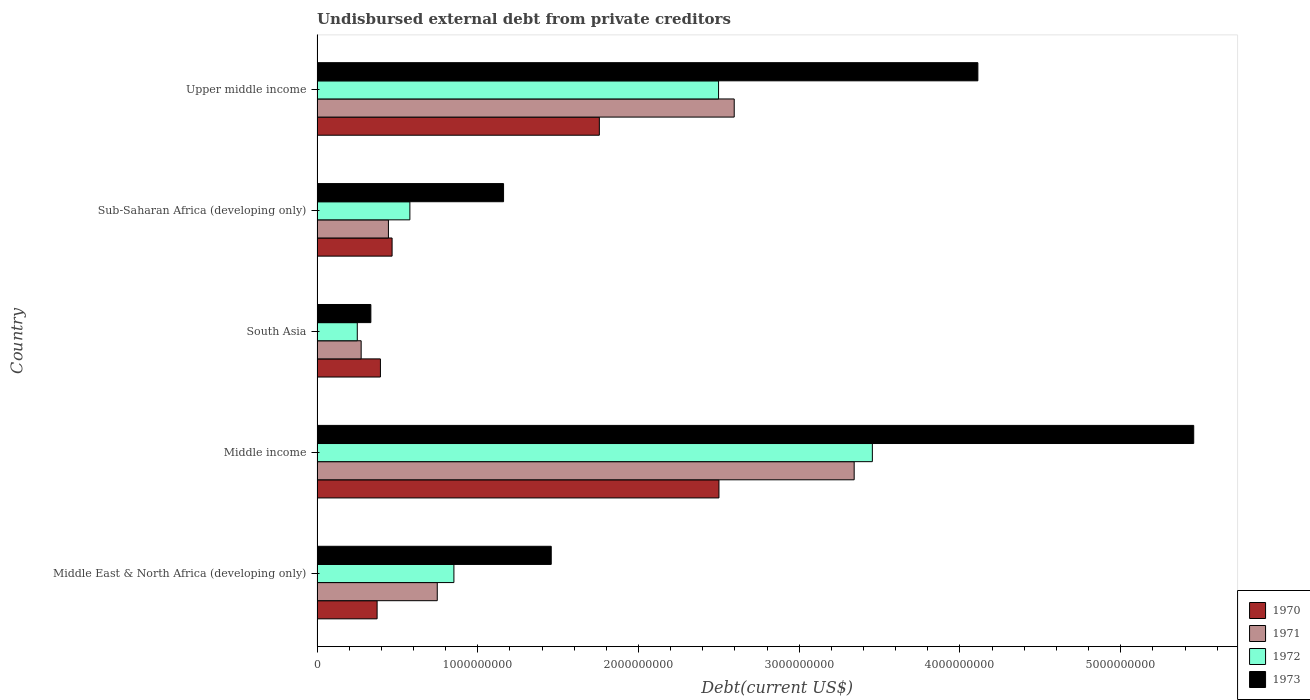How many groups of bars are there?
Make the answer very short. 5. Are the number of bars on each tick of the Y-axis equal?
Make the answer very short. Yes. What is the label of the 5th group of bars from the top?
Make the answer very short. Middle East & North Africa (developing only). What is the total debt in 1973 in Upper middle income?
Your response must be concise. 4.11e+09. Across all countries, what is the maximum total debt in 1971?
Ensure brevity in your answer.  3.34e+09. Across all countries, what is the minimum total debt in 1971?
Offer a very short reply. 2.74e+08. In which country was the total debt in 1970 minimum?
Give a very brief answer. Middle East & North Africa (developing only). What is the total total debt in 1973 in the graph?
Offer a very short reply. 1.25e+1. What is the difference between the total debt in 1970 in South Asia and that in Upper middle income?
Your answer should be compact. -1.36e+09. What is the difference between the total debt in 1971 in Sub-Saharan Africa (developing only) and the total debt in 1973 in Middle income?
Keep it short and to the point. -5.01e+09. What is the average total debt in 1971 per country?
Make the answer very short. 1.48e+09. What is the difference between the total debt in 1970 and total debt in 1972 in South Asia?
Your answer should be very brief. 1.44e+08. What is the ratio of the total debt in 1973 in Middle East & North Africa (developing only) to that in Sub-Saharan Africa (developing only)?
Your answer should be very brief. 1.26. Is the total debt in 1972 in Middle income less than that in South Asia?
Your answer should be compact. No. Is the difference between the total debt in 1970 in Middle income and Sub-Saharan Africa (developing only) greater than the difference between the total debt in 1972 in Middle income and Sub-Saharan Africa (developing only)?
Offer a terse response. No. What is the difference between the highest and the second highest total debt in 1972?
Offer a very short reply. 9.57e+08. What is the difference between the highest and the lowest total debt in 1971?
Ensure brevity in your answer.  3.07e+09. Is it the case that in every country, the sum of the total debt in 1972 and total debt in 1970 is greater than the sum of total debt in 1973 and total debt in 1971?
Your answer should be compact. No. Is it the case that in every country, the sum of the total debt in 1970 and total debt in 1973 is greater than the total debt in 1971?
Keep it short and to the point. Yes. Are the values on the major ticks of X-axis written in scientific E-notation?
Provide a succinct answer. No. How many legend labels are there?
Offer a terse response. 4. What is the title of the graph?
Make the answer very short. Undisbursed external debt from private creditors. What is the label or title of the X-axis?
Provide a short and direct response. Debt(current US$). What is the label or title of the Y-axis?
Ensure brevity in your answer.  Country. What is the Debt(current US$) of 1970 in Middle East & North Africa (developing only)?
Give a very brief answer. 3.74e+08. What is the Debt(current US$) in 1971 in Middle East & North Africa (developing only)?
Offer a terse response. 7.48e+08. What is the Debt(current US$) in 1972 in Middle East & North Africa (developing only)?
Your response must be concise. 8.51e+08. What is the Debt(current US$) of 1973 in Middle East & North Africa (developing only)?
Ensure brevity in your answer.  1.46e+09. What is the Debt(current US$) of 1970 in Middle income?
Offer a terse response. 2.50e+09. What is the Debt(current US$) of 1971 in Middle income?
Make the answer very short. 3.34e+09. What is the Debt(current US$) of 1972 in Middle income?
Offer a very short reply. 3.45e+09. What is the Debt(current US$) in 1973 in Middle income?
Your answer should be very brief. 5.45e+09. What is the Debt(current US$) of 1970 in South Asia?
Keep it short and to the point. 3.94e+08. What is the Debt(current US$) of 1971 in South Asia?
Ensure brevity in your answer.  2.74e+08. What is the Debt(current US$) of 1972 in South Asia?
Provide a succinct answer. 2.50e+08. What is the Debt(current US$) in 1973 in South Asia?
Your answer should be compact. 3.35e+08. What is the Debt(current US$) of 1970 in Sub-Saharan Africa (developing only)?
Your answer should be compact. 4.67e+08. What is the Debt(current US$) in 1971 in Sub-Saharan Africa (developing only)?
Provide a short and direct response. 4.44e+08. What is the Debt(current US$) of 1972 in Sub-Saharan Africa (developing only)?
Make the answer very short. 5.77e+08. What is the Debt(current US$) in 1973 in Sub-Saharan Africa (developing only)?
Keep it short and to the point. 1.16e+09. What is the Debt(current US$) of 1970 in Upper middle income?
Your response must be concise. 1.76e+09. What is the Debt(current US$) in 1971 in Upper middle income?
Make the answer very short. 2.60e+09. What is the Debt(current US$) of 1972 in Upper middle income?
Offer a very short reply. 2.50e+09. What is the Debt(current US$) in 1973 in Upper middle income?
Your answer should be very brief. 4.11e+09. Across all countries, what is the maximum Debt(current US$) in 1970?
Give a very brief answer. 2.50e+09. Across all countries, what is the maximum Debt(current US$) in 1971?
Give a very brief answer. 3.34e+09. Across all countries, what is the maximum Debt(current US$) in 1972?
Keep it short and to the point. 3.45e+09. Across all countries, what is the maximum Debt(current US$) of 1973?
Your response must be concise. 5.45e+09. Across all countries, what is the minimum Debt(current US$) in 1970?
Your answer should be very brief. 3.74e+08. Across all countries, what is the minimum Debt(current US$) of 1971?
Provide a succinct answer. 2.74e+08. Across all countries, what is the minimum Debt(current US$) in 1972?
Offer a very short reply. 2.50e+08. Across all countries, what is the minimum Debt(current US$) in 1973?
Your response must be concise. 3.35e+08. What is the total Debt(current US$) in 1970 in the graph?
Your answer should be compact. 5.49e+09. What is the total Debt(current US$) of 1971 in the graph?
Provide a short and direct response. 7.40e+09. What is the total Debt(current US$) of 1972 in the graph?
Provide a short and direct response. 7.63e+09. What is the total Debt(current US$) of 1973 in the graph?
Keep it short and to the point. 1.25e+1. What is the difference between the Debt(current US$) of 1970 in Middle East & North Africa (developing only) and that in Middle income?
Your answer should be very brief. -2.13e+09. What is the difference between the Debt(current US$) of 1971 in Middle East & North Africa (developing only) and that in Middle income?
Provide a succinct answer. -2.59e+09. What is the difference between the Debt(current US$) in 1972 in Middle East & North Africa (developing only) and that in Middle income?
Provide a succinct answer. -2.60e+09. What is the difference between the Debt(current US$) of 1973 in Middle East & North Africa (developing only) and that in Middle income?
Make the answer very short. -4.00e+09. What is the difference between the Debt(current US$) in 1970 in Middle East & North Africa (developing only) and that in South Asia?
Offer a terse response. -2.07e+07. What is the difference between the Debt(current US$) in 1971 in Middle East & North Africa (developing only) and that in South Asia?
Your answer should be very brief. 4.74e+08. What is the difference between the Debt(current US$) of 1972 in Middle East & North Africa (developing only) and that in South Asia?
Your answer should be very brief. 6.01e+08. What is the difference between the Debt(current US$) in 1973 in Middle East & North Africa (developing only) and that in South Asia?
Offer a terse response. 1.12e+09. What is the difference between the Debt(current US$) in 1970 in Middle East & North Africa (developing only) and that in Sub-Saharan Africa (developing only)?
Ensure brevity in your answer.  -9.32e+07. What is the difference between the Debt(current US$) of 1971 in Middle East & North Africa (developing only) and that in Sub-Saharan Africa (developing only)?
Give a very brief answer. 3.04e+08. What is the difference between the Debt(current US$) of 1972 in Middle East & North Africa (developing only) and that in Sub-Saharan Africa (developing only)?
Provide a short and direct response. 2.74e+08. What is the difference between the Debt(current US$) of 1973 in Middle East & North Africa (developing only) and that in Sub-Saharan Africa (developing only)?
Your answer should be compact. 2.97e+08. What is the difference between the Debt(current US$) of 1970 in Middle East & North Africa (developing only) and that in Upper middle income?
Give a very brief answer. -1.38e+09. What is the difference between the Debt(current US$) of 1971 in Middle East & North Africa (developing only) and that in Upper middle income?
Give a very brief answer. -1.85e+09. What is the difference between the Debt(current US$) in 1972 in Middle East & North Africa (developing only) and that in Upper middle income?
Offer a very short reply. -1.65e+09. What is the difference between the Debt(current US$) in 1973 in Middle East & North Africa (developing only) and that in Upper middle income?
Your response must be concise. -2.65e+09. What is the difference between the Debt(current US$) of 1970 in Middle income and that in South Asia?
Your answer should be very brief. 2.11e+09. What is the difference between the Debt(current US$) in 1971 in Middle income and that in South Asia?
Ensure brevity in your answer.  3.07e+09. What is the difference between the Debt(current US$) in 1972 in Middle income and that in South Asia?
Ensure brevity in your answer.  3.20e+09. What is the difference between the Debt(current US$) in 1973 in Middle income and that in South Asia?
Make the answer very short. 5.12e+09. What is the difference between the Debt(current US$) in 1970 in Middle income and that in Sub-Saharan Africa (developing only)?
Ensure brevity in your answer.  2.03e+09. What is the difference between the Debt(current US$) of 1971 in Middle income and that in Sub-Saharan Africa (developing only)?
Provide a succinct answer. 2.90e+09. What is the difference between the Debt(current US$) of 1972 in Middle income and that in Sub-Saharan Africa (developing only)?
Your answer should be compact. 2.88e+09. What is the difference between the Debt(current US$) of 1973 in Middle income and that in Sub-Saharan Africa (developing only)?
Keep it short and to the point. 4.29e+09. What is the difference between the Debt(current US$) in 1970 in Middle income and that in Upper middle income?
Provide a succinct answer. 7.44e+08. What is the difference between the Debt(current US$) of 1971 in Middle income and that in Upper middle income?
Make the answer very short. 7.46e+08. What is the difference between the Debt(current US$) of 1972 in Middle income and that in Upper middle income?
Provide a succinct answer. 9.57e+08. What is the difference between the Debt(current US$) of 1973 in Middle income and that in Upper middle income?
Your answer should be very brief. 1.34e+09. What is the difference between the Debt(current US$) of 1970 in South Asia and that in Sub-Saharan Africa (developing only)?
Provide a succinct answer. -7.26e+07. What is the difference between the Debt(current US$) of 1971 in South Asia and that in Sub-Saharan Africa (developing only)?
Offer a terse response. -1.70e+08. What is the difference between the Debt(current US$) in 1972 in South Asia and that in Sub-Saharan Africa (developing only)?
Provide a short and direct response. -3.27e+08. What is the difference between the Debt(current US$) of 1973 in South Asia and that in Sub-Saharan Africa (developing only)?
Keep it short and to the point. -8.26e+08. What is the difference between the Debt(current US$) of 1970 in South Asia and that in Upper middle income?
Offer a terse response. -1.36e+09. What is the difference between the Debt(current US$) of 1971 in South Asia and that in Upper middle income?
Your response must be concise. -2.32e+09. What is the difference between the Debt(current US$) of 1972 in South Asia and that in Upper middle income?
Offer a very short reply. -2.25e+09. What is the difference between the Debt(current US$) of 1973 in South Asia and that in Upper middle income?
Ensure brevity in your answer.  -3.78e+09. What is the difference between the Debt(current US$) in 1970 in Sub-Saharan Africa (developing only) and that in Upper middle income?
Make the answer very short. -1.29e+09. What is the difference between the Debt(current US$) of 1971 in Sub-Saharan Africa (developing only) and that in Upper middle income?
Ensure brevity in your answer.  -2.15e+09. What is the difference between the Debt(current US$) in 1972 in Sub-Saharan Africa (developing only) and that in Upper middle income?
Ensure brevity in your answer.  -1.92e+09. What is the difference between the Debt(current US$) of 1973 in Sub-Saharan Africa (developing only) and that in Upper middle income?
Your answer should be compact. -2.95e+09. What is the difference between the Debt(current US$) of 1970 in Middle East & North Africa (developing only) and the Debt(current US$) of 1971 in Middle income?
Ensure brevity in your answer.  -2.97e+09. What is the difference between the Debt(current US$) in 1970 in Middle East & North Africa (developing only) and the Debt(current US$) in 1972 in Middle income?
Provide a succinct answer. -3.08e+09. What is the difference between the Debt(current US$) in 1970 in Middle East & North Africa (developing only) and the Debt(current US$) in 1973 in Middle income?
Make the answer very short. -5.08e+09. What is the difference between the Debt(current US$) of 1971 in Middle East & North Africa (developing only) and the Debt(current US$) of 1972 in Middle income?
Offer a very short reply. -2.71e+09. What is the difference between the Debt(current US$) in 1971 in Middle East & North Africa (developing only) and the Debt(current US$) in 1973 in Middle income?
Your answer should be very brief. -4.71e+09. What is the difference between the Debt(current US$) of 1972 in Middle East & North Africa (developing only) and the Debt(current US$) of 1973 in Middle income?
Offer a terse response. -4.60e+09. What is the difference between the Debt(current US$) in 1970 in Middle East & North Africa (developing only) and the Debt(current US$) in 1971 in South Asia?
Your answer should be compact. 9.92e+07. What is the difference between the Debt(current US$) of 1970 in Middle East & North Africa (developing only) and the Debt(current US$) of 1972 in South Asia?
Offer a terse response. 1.23e+08. What is the difference between the Debt(current US$) of 1970 in Middle East & North Africa (developing only) and the Debt(current US$) of 1973 in South Asia?
Your response must be concise. 3.88e+07. What is the difference between the Debt(current US$) of 1971 in Middle East & North Africa (developing only) and the Debt(current US$) of 1972 in South Asia?
Provide a succinct answer. 4.98e+08. What is the difference between the Debt(current US$) of 1971 in Middle East & North Africa (developing only) and the Debt(current US$) of 1973 in South Asia?
Offer a very short reply. 4.13e+08. What is the difference between the Debt(current US$) in 1972 in Middle East & North Africa (developing only) and the Debt(current US$) in 1973 in South Asia?
Make the answer very short. 5.17e+08. What is the difference between the Debt(current US$) in 1970 in Middle East & North Africa (developing only) and the Debt(current US$) in 1971 in Sub-Saharan Africa (developing only)?
Your response must be concise. -7.04e+07. What is the difference between the Debt(current US$) in 1970 in Middle East & North Africa (developing only) and the Debt(current US$) in 1972 in Sub-Saharan Africa (developing only)?
Ensure brevity in your answer.  -2.04e+08. What is the difference between the Debt(current US$) of 1970 in Middle East & North Africa (developing only) and the Debt(current US$) of 1973 in Sub-Saharan Africa (developing only)?
Offer a terse response. -7.87e+08. What is the difference between the Debt(current US$) of 1971 in Middle East & North Africa (developing only) and the Debt(current US$) of 1972 in Sub-Saharan Africa (developing only)?
Offer a very short reply. 1.70e+08. What is the difference between the Debt(current US$) in 1971 in Middle East & North Africa (developing only) and the Debt(current US$) in 1973 in Sub-Saharan Africa (developing only)?
Your response must be concise. -4.12e+08. What is the difference between the Debt(current US$) of 1972 in Middle East & North Africa (developing only) and the Debt(current US$) of 1973 in Sub-Saharan Africa (developing only)?
Give a very brief answer. -3.09e+08. What is the difference between the Debt(current US$) of 1970 in Middle East & North Africa (developing only) and the Debt(current US$) of 1971 in Upper middle income?
Offer a terse response. -2.22e+09. What is the difference between the Debt(current US$) in 1970 in Middle East & North Africa (developing only) and the Debt(current US$) in 1972 in Upper middle income?
Offer a very short reply. -2.12e+09. What is the difference between the Debt(current US$) in 1970 in Middle East & North Africa (developing only) and the Debt(current US$) in 1973 in Upper middle income?
Make the answer very short. -3.74e+09. What is the difference between the Debt(current US$) of 1971 in Middle East & North Africa (developing only) and the Debt(current US$) of 1972 in Upper middle income?
Give a very brief answer. -1.75e+09. What is the difference between the Debt(current US$) of 1971 in Middle East & North Africa (developing only) and the Debt(current US$) of 1973 in Upper middle income?
Make the answer very short. -3.36e+09. What is the difference between the Debt(current US$) of 1972 in Middle East & North Africa (developing only) and the Debt(current US$) of 1973 in Upper middle income?
Provide a succinct answer. -3.26e+09. What is the difference between the Debt(current US$) of 1970 in Middle income and the Debt(current US$) of 1971 in South Asia?
Offer a terse response. 2.23e+09. What is the difference between the Debt(current US$) in 1970 in Middle income and the Debt(current US$) in 1972 in South Asia?
Provide a succinct answer. 2.25e+09. What is the difference between the Debt(current US$) in 1970 in Middle income and the Debt(current US$) in 1973 in South Asia?
Your answer should be compact. 2.17e+09. What is the difference between the Debt(current US$) of 1971 in Middle income and the Debt(current US$) of 1972 in South Asia?
Provide a short and direct response. 3.09e+09. What is the difference between the Debt(current US$) in 1971 in Middle income and the Debt(current US$) in 1973 in South Asia?
Your answer should be compact. 3.01e+09. What is the difference between the Debt(current US$) of 1972 in Middle income and the Debt(current US$) of 1973 in South Asia?
Offer a terse response. 3.12e+09. What is the difference between the Debt(current US$) of 1970 in Middle income and the Debt(current US$) of 1971 in Sub-Saharan Africa (developing only)?
Provide a succinct answer. 2.06e+09. What is the difference between the Debt(current US$) in 1970 in Middle income and the Debt(current US$) in 1972 in Sub-Saharan Africa (developing only)?
Keep it short and to the point. 1.92e+09. What is the difference between the Debt(current US$) in 1970 in Middle income and the Debt(current US$) in 1973 in Sub-Saharan Africa (developing only)?
Offer a very short reply. 1.34e+09. What is the difference between the Debt(current US$) of 1971 in Middle income and the Debt(current US$) of 1972 in Sub-Saharan Africa (developing only)?
Offer a very short reply. 2.76e+09. What is the difference between the Debt(current US$) of 1971 in Middle income and the Debt(current US$) of 1973 in Sub-Saharan Africa (developing only)?
Your response must be concise. 2.18e+09. What is the difference between the Debt(current US$) in 1972 in Middle income and the Debt(current US$) in 1973 in Sub-Saharan Africa (developing only)?
Provide a succinct answer. 2.29e+09. What is the difference between the Debt(current US$) in 1970 in Middle income and the Debt(current US$) in 1971 in Upper middle income?
Keep it short and to the point. -9.50e+07. What is the difference between the Debt(current US$) in 1970 in Middle income and the Debt(current US$) in 1972 in Upper middle income?
Make the answer very short. 2.49e+06. What is the difference between the Debt(current US$) of 1970 in Middle income and the Debt(current US$) of 1973 in Upper middle income?
Offer a very short reply. -1.61e+09. What is the difference between the Debt(current US$) in 1971 in Middle income and the Debt(current US$) in 1972 in Upper middle income?
Your answer should be very brief. 8.44e+08. What is the difference between the Debt(current US$) in 1971 in Middle income and the Debt(current US$) in 1973 in Upper middle income?
Your answer should be very brief. -7.70e+08. What is the difference between the Debt(current US$) in 1972 in Middle income and the Debt(current US$) in 1973 in Upper middle income?
Ensure brevity in your answer.  -6.57e+08. What is the difference between the Debt(current US$) in 1970 in South Asia and the Debt(current US$) in 1971 in Sub-Saharan Africa (developing only)?
Your answer should be very brief. -4.98e+07. What is the difference between the Debt(current US$) in 1970 in South Asia and the Debt(current US$) in 1972 in Sub-Saharan Africa (developing only)?
Offer a terse response. -1.83e+08. What is the difference between the Debt(current US$) in 1970 in South Asia and the Debt(current US$) in 1973 in Sub-Saharan Africa (developing only)?
Ensure brevity in your answer.  -7.66e+08. What is the difference between the Debt(current US$) in 1971 in South Asia and the Debt(current US$) in 1972 in Sub-Saharan Africa (developing only)?
Offer a very short reply. -3.03e+08. What is the difference between the Debt(current US$) of 1971 in South Asia and the Debt(current US$) of 1973 in Sub-Saharan Africa (developing only)?
Provide a succinct answer. -8.86e+08. What is the difference between the Debt(current US$) in 1972 in South Asia and the Debt(current US$) in 1973 in Sub-Saharan Africa (developing only)?
Give a very brief answer. -9.10e+08. What is the difference between the Debt(current US$) of 1970 in South Asia and the Debt(current US$) of 1971 in Upper middle income?
Give a very brief answer. -2.20e+09. What is the difference between the Debt(current US$) of 1970 in South Asia and the Debt(current US$) of 1972 in Upper middle income?
Keep it short and to the point. -2.10e+09. What is the difference between the Debt(current US$) of 1970 in South Asia and the Debt(current US$) of 1973 in Upper middle income?
Give a very brief answer. -3.72e+09. What is the difference between the Debt(current US$) of 1971 in South Asia and the Debt(current US$) of 1972 in Upper middle income?
Provide a succinct answer. -2.22e+09. What is the difference between the Debt(current US$) in 1971 in South Asia and the Debt(current US$) in 1973 in Upper middle income?
Offer a terse response. -3.84e+09. What is the difference between the Debt(current US$) of 1972 in South Asia and the Debt(current US$) of 1973 in Upper middle income?
Keep it short and to the point. -3.86e+09. What is the difference between the Debt(current US$) in 1970 in Sub-Saharan Africa (developing only) and the Debt(current US$) in 1971 in Upper middle income?
Offer a terse response. -2.13e+09. What is the difference between the Debt(current US$) of 1970 in Sub-Saharan Africa (developing only) and the Debt(current US$) of 1972 in Upper middle income?
Offer a very short reply. -2.03e+09. What is the difference between the Debt(current US$) in 1970 in Sub-Saharan Africa (developing only) and the Debt(current US$) in 1973 in Upper middle income?
Your answer should be compact. -3.64e+09. What is the difference between the Debt(current US$) in 1971 in Sub-Saharan Africa (developing only) and the Debt(current US$) in 1972 in Upper middle income?
Keep it short and to the point. -2.05e+09. What is the difference between the Debt(current US$) of 1971 in Sub-Saharan Africa (developing only) and the Debt(current US$) of 1973 in Upper middle income?
Give a very brief answer. -3.67e+09. What is the difference between the Debt(current US$) of 1972 in Sub-Saharan Africa (developing only) and the Debt(current US$) of 1973 in Upper middle income?
Provide a short and direct response. -3.53e+09. What is the average Debt(current US$) in 1970 per country?
Your answer should be very brief. 1.10e+09. What is the average Debt(current US$) of 1971 per country?
Keep it short and to the point. 1.48e+09. What is the average Debt(current US$) of 1972 per country?
Provide a short and direct response. 1.53e+09. What is the average Debt(current US$) of 1973 per country?
Your answer should be compact. 2.50e+09. What is the difference between the Debt(current US$) in 1970 and Debt(current US$) in 1971 in Middle East & North Africa (developing only)?
Your answer should be compact. -3.74e+08. What is the difference between the Debt(current US$) of 1970 and Debt(current US$) of 1972 in Middle East & North Africa (developing only)?
Your answer should be very brief. -4.78e+08. What is the difference between the Debt(current US$) of 1970 and Debt(current US$) of 1973 in Middle East & North Africa (developing only)?
Provide a succinct answer. -1.08e+09. What is the difference between the Debt(current US$) of 1971 and Debt(current US$) of 1972 in Middle East & North Africa (developing only)?
Keep it short and to the point. -1.04e+08. What is the difference between the Debt(current US$) of 1971 and Debt(current US$) of 1973 in Middle East & North Africa (developing only)?
Your answer should be compact. -7.09e+08. What is the difference between the Debt(current US$) of 1972 and Debt(current US$) of 1973 in Middle East & North Africa (developing only)?
Provide a short and direct response. -6.06e+08. What is the difference between the Debt(current US$) of 1970 and Debt(current US$) of 1971 in Middle income?
Your response must be concise. -8.41e+08. What is the difference between the Debt(current US$) of 1970 and Debt(current US$) of 1972 in Middle income?
Provide a short and direct response. -9.54e+08. What is the difference between the Debt(current US$) of 1970 and Debt(current US$) of 1973 in Middle income?
Provide a succinct answer. -2.95e+09. What is the difference between the Debt(current US$) of 1971 and Debt(current US$) of 1972 in Middle income?
Make the answer very short. -1.13e+08. What is the difference between the Debt(current US$) of 1971 and Debt(current US$) of 1973 in Middle income?
Keep it short and to the point. -2.11e+09. What is the difference between the Debt(current US$) in 1972 and Debt(current US$) in 1973 in Middle income?
Make the answer very short. -2.00e+09. What is the difference between the Debt(current US$) in 1970 and Debt(current US$) in 1971 in South Asia?
Keep it short and to the point. 1.20e+08. What is the difference between the Debt(current US$) of 1970 and Debt(current US$) of 1972 in South Asia?
Your answer should be compact. 1.44e+08. What is the difference between the Debt(current US$) of 1970 and Debt(current US$) of 1973 in South Asia?
Your response must be concise. 5.95e+07. What is the difference between the Debt(current US$) of 1971 and Debt(current US$) of 1972 in South Asia?
Make the answer very short. 2.41e+07. What is the difference between the Debt(current US$) in 1971 and Debt(current US$) in 1973 in South Asia?
Make the answer very short. -6.04e+07. What is the difference between the Debt(current US$) in 1972 and Debt(current US$) in 1973 in South Asia?
Provide a succinct answer. -8.45e+07. What is the difference between the Debt(current US$) in 1970 and Debt(current US$) in 1971 in Sub-Saharan Africa (developing only)?
Provide a succinct answer. 2.28e+07. What is the difference between the Debt(current US$) in 1970 and Debt(current US$) in 1972 in Sub-Saharan Africa (developing only)?
Give a very brief answer. -1.11e+08. What is the difference between the Debt(current US$) in 1970 and Debt(current US$) in 1973 in Sub-Saharan Africa (developing only)?
Provide a succinct answer. -6.94e+08. What is the difference between the Debt(current US$) in 1971 and Debt(current US$) in 1972 in Sub-Saharan Africa (developing only)?
Provide a short and direct response. -1.33e+08. What is the difference between the Debt(current US$) of 1971 and Debt(current US$) of 1973 in Sub-Saharan Africa (developing only)?
Your answer should be very brief. -7.16e+08. What is the difference between the Debt(current US$) in 1972 and Debt(current US$) in 1973 in Sub-Saharan Africa (developing only)?
Your answer should be very brief. -5.83e+08. What is the difference between the Debt(current US$) in 1970 and Debt(current US$) in 1971 in Upper middle income?
Give a very brief answer. -8.39e+08. What is the difference between the Debt(current US$) in 1970 and Debt(current US$) in 1972 in Upper middle income?
Your response must be concise. -7.42e+08. What is the difference between the Debt(current US$) of 1970 and Debt(current US$) of 1973 in Upper middle income?
Offer a very short reply. -2.36e+09. What is the difference between the Debt(current US$) in 1971 and Debt(current US$) in 1972 in Upper middle income?
Provide a short and direct response. 9.75e+07. What is the difference between the Debt(current US$) of 1971 and Debt(current US$) of 1973 in Upper middle income?
Offer a terse response. -1.52e+09. What is the difference between the Debt(current US$) in 1972 and Debt(current US$) in 1973 in Upper middle income?
Offer a very short reply. -1.61e+09. What is the ratio of the Debt(current US$) of 1970 in Middle East & North Africa (developing only) to that in Middle income?
Give a very brief answer. 0.15. What is the ratio of the Debt(current US$) of 1971 in Middle East & North Africa (developing only) to that in Middle income?
Offer a very short reply. 0.22. What is the ratio of the Debt(current US$) of 1972 in Middle East & North Africa (developing only) to that in Middle income?
Provide a short and direct response. 0.25. What is the ratio of the Debt(current US$) in 1973 in Middle East & North Africa (developing only) to that in Middle income?
Offer a very short reply. 0.27. What is the ratio of the Debt(current US$) in 1970 in Middle East & North Africa (developing only) to that in South Asia?
Ensure brevity in your answer.  0.95. What is the ratio of the Debt(current US$) of 1971 in Middle East & North Africa (developing only) to that in South Asia?
Your answer should be very brief. 2.73. What is the ratio of the Debt(current US$) in 1972 in Middle East & North Africa (developing only) to that in South Asia?
Make the answer very short. 3.4. What is the ratio of the Debt(current US$) of 1973 in Middle East & North Africa (developing only) to that in South Asia?
Your response must be concise. 4.35. What is the ratio of the Debt(current US$) in 1970 in Middle East & North Africa (developing only) to that in Sub-Saharan Africa (developing only)?
Provide a short and direct response. 0.8. What is the ratio of the Debt(current US$) in 1971 in Middle East & North Africa (developing only) to that in Sub-Saharan Africa (developing only)?
Ensure brevity in your answer.  1.68. What is the ratio of the Debt(current US$) of 1972 in Middle East & North Africa (developing only) to that in Sub-Saharan Africa (developing only)?
Keep it short and to the point. 1.47. What is the ratio of the Debt(current US$) in 1973 in Middle East & North Africa (developing only) to that in Sub-Saharan Africa (developing only)?
Make the answer very short. 1.26. What is the ratio of the Debt(current US$) of 1970 in Middle East & North Africa (developing only) to that in Upper middle income?
Your answer should be very brief. 0.21. What is the ratio of the Debt(current US$) of 1971 in Middle East & North Africa (developing only) to that in Upper middle income?
Provide a short and direct response. 0.29. What is the ratio of the Debt(current US$) of 1972 in Middle East & North Africa (developing only) to that in Upper middle income?
Offer a terse response. 0.34. What is the ratio of the Debt(current US$) of 1973 in Middle East & North Africa (developing only) to that in Upper middle income?
Your answer should be compact. 0.35. What is the ratio of the Debt(current US$) of 1970 in Middle income to that in South Asia?
Make the answer very short. 6.34. What is the ratio of the Debt(current US$) in 1971 in Middle income to that in South Asia?
Your answer should be compact. 12.18. What is the ratio of the Debt(current US$) in 1972 in Middle income to that in South Asia?
Offer a terse response. 13.8. What is the ratio of the Debt(current US$) of 1973 in Middle income to that in South Asia?
Offer a very short reply. 16.29. What is the ratio of the Debt(current US$) in 1970 in Middle income to that in Sub-Saharan Africa (developing only)?
Keep it short and to the point. 5.36. What is the ratio of the Debt(current US$) of 1971 in Middle income to that in Sub-Saharan Africa (developing only)?
Provide a short and direct response. 7.53. What is the ratio of the Debt(current US$) in 1972 in Middle income to that in Sub-Saharan Africa (developing only)?
Provide a short and direct response. 5.98. What is the ratio of the Debt(current US$) of 1973 in Middle income to that in Sub-Saharan Africa (developing only)?
Ensure brevity in your answer.  4.7. What is the ratio of the Debt(current US$) in 1970 in Middle income to that in Upper middle income?
Give a very brief answer. 1.42. What is the ratio of the Debt(current US$) in 1971 in Middle income to that in Upper middle income?
Keep it short and to the point. 1.29. What is the ratio of the Debt(current US$) of 1972 in Middle income to that in Upper middle income?
Make the answer very short. 1.38. What is the ratio of the Debt(current US$) in 1973 in Middle income to that in Upper middle income?
Offer a very short reply. 1.33. What is the ratio of the Debt(current US$) of 1970 in South Asia to that in Sub-Saharan Africa (developing only)?
Make the answer very short. 0.84. What is the ratio of the Debt(current US$) of 1971 in South Asia to that in Sub-Saharan Africa (developing only)?
Keep it short and to the point. 0.62. What is the ratio of the Debt(current US$) in 1972 in South Asia to that in Sub-Saharan Africa (developing only)?
Offer a terse response. 0.43. What is the ratio of the Debt(current US$) of 1973 in South Asia to that in Sub-Saharan Africa (developing only)?
Offer a very short reply. 0.29. What is the ratio of the Debt(current US$) of 1970 in South Asia to that in Upper middle income?
Your answer should be compact. 0.22. What is the ratio of the Debt(current US$) in 1971 in South Asia to that in Upper middle income?
Your answer should be very brief. 0.11. What is the ratio of the Debt(current US$) of 1972 in South Asia to that in Upper middle income?
Give a very brief answer. 0.1. What is the ratio of the Debt(current US$) in 1973 in South Asia to that in Upper middle income?
Your response must be concise. 0.08. What is the ratio of the Debt(current US$) in 1970 in Sub-Saharan Africa (developing only) to that in Upper middle income?
Keep it short and to the point. 0.27. What is the ratio of the Debt(current US$) of 1971 in Sub-Saharan Africa (developing only) to that in Upper middle income?
Ensure brevity in your answer.  0.17. What is the ratio of the Debt(current US$) of 1972 in Sub-Saharan Africa (developing only) to that in Upper middle income?
Offer a very short reply. 0.23. What is the ratio of the Debt(current US$) in 1973 in Sub-Saharan Africa (developing only) to that in Upper middle income?
Your answer should be compact. 0.28. What is the difference between the highest and the second highest Debt(current US$) of 1970?
Ensure brevity in your answer.  7.44e+08. What is the difference between the highest and the second highest Debt(current US$) in 1971?
Give a very brief answer. 7.46e+08. What is the difference between the highest and the second highest Debt(current US$) of 1972?
Keep it short and to the point. 9.57e+08. What is the difference between the highest and the second highest Debt(current US$) in 1973?
Give a very brief answer. 1.34e+09. What is the difference between the highest and the lowest Debt(current US$) in 1970?
Ensure brevity in your answer.  2.13e+09. What is the difference between the highest and the lowest Debt(current US$) in 1971?
Offer a terse response. 3.07e+09. What is the difference between the highest and the lowest Debt(current US$) in 1972?
Offer a terse response. 3.20e+09. What is the difference between the highest and the lowest Debt(current US$) in 1973?
Offer a terse response. 5.12e+09. 